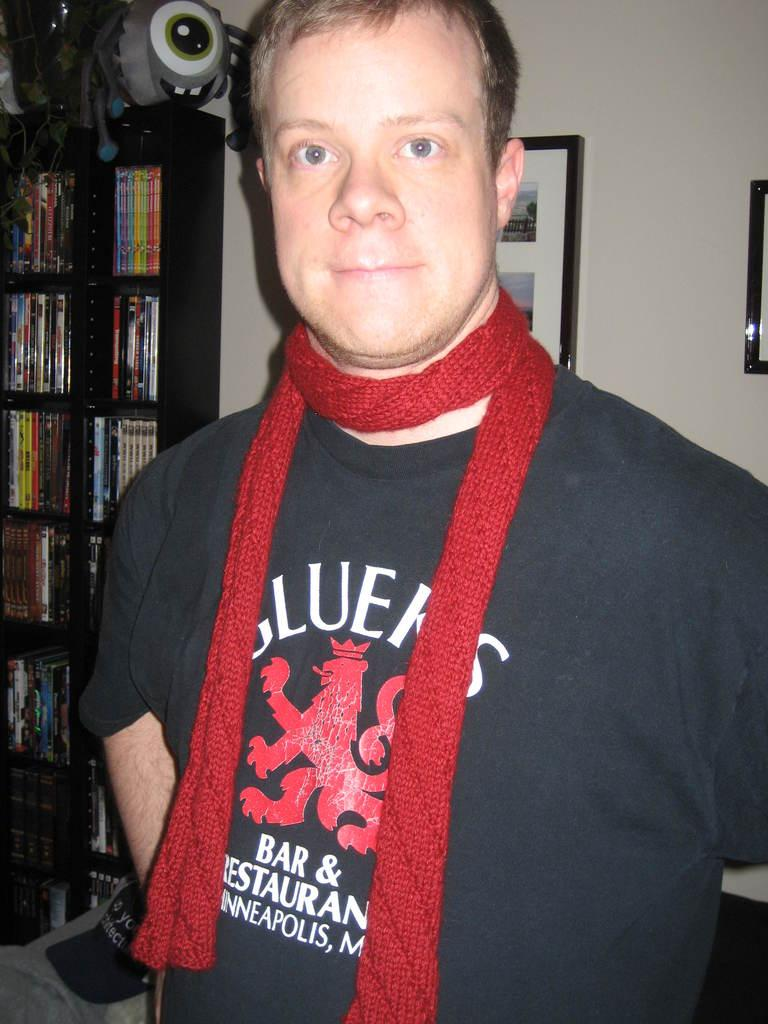<image>
Write a terse but informative summary of the picture. A man wearing a black and red shirt that says GLUEKS on it in white letters. 